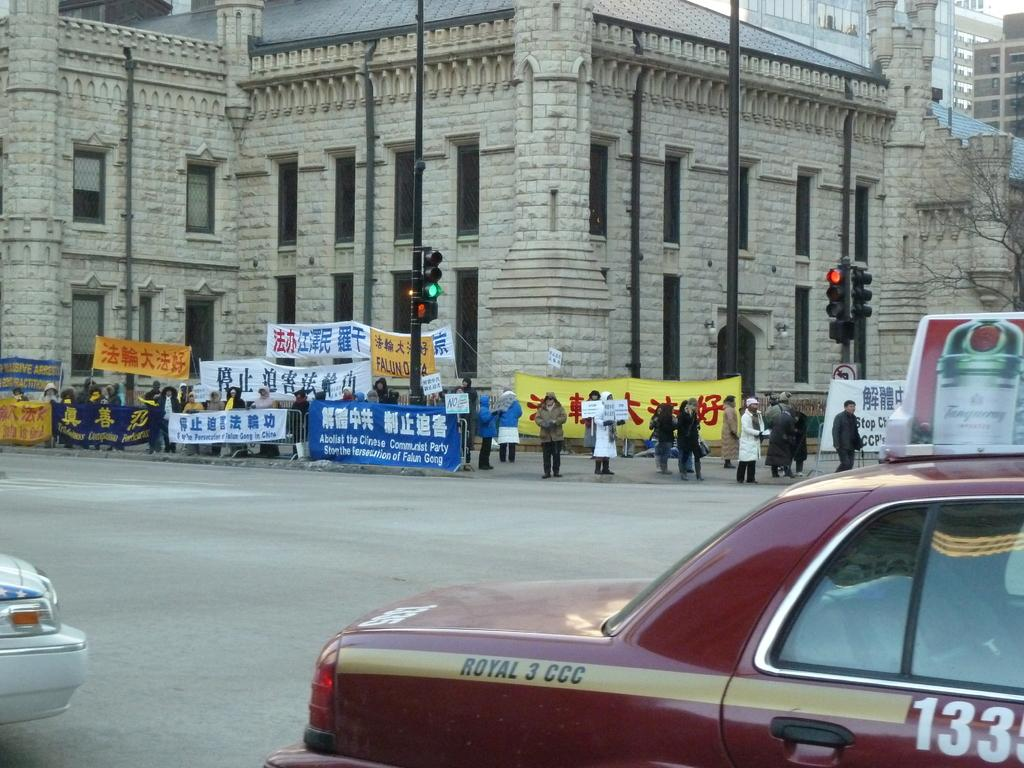<image>
Relay a brief, clear account of the picture shown. A group of protesters are holding signs by an intersection and one of the signs says Abolish the Chinese Communist Party. 